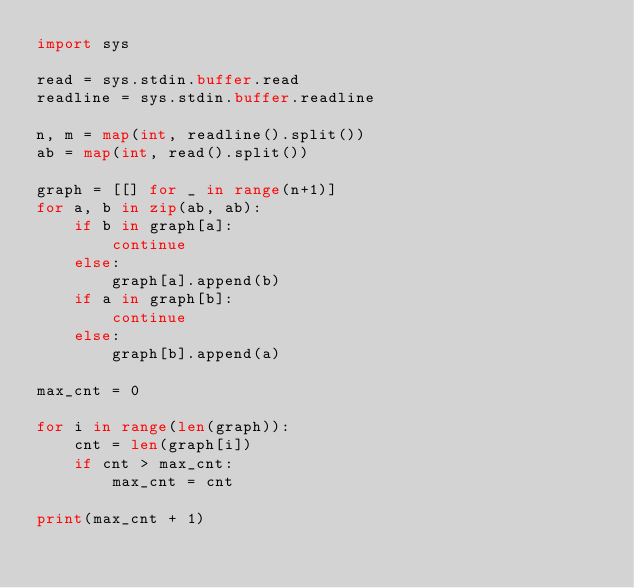Convert code to text. <code><loc_0><loc_0><loc_500><loc_500><_Python_>import sys

read = sys.stdin.buffer.read
readline = sys.stdin.buffer.readline

n, m = map(int, readline().split())
ab = map(int, read().split())

graph = [[] for _ in range(n+1)]
for a, b in zip(ab, ab):
    if b in graph[a]:
        continue
    else:
        graph[a].append(b)
    if a in graph[b]:
        continue
    else:
        graph[b].append(a)

max_cnt = 0

for i in range(len(graph)):
    cnt = len(graph[i])
    if cnt > max_cnt:
        max_cnt = cnt

print(max_cnt + 1)
</code> 